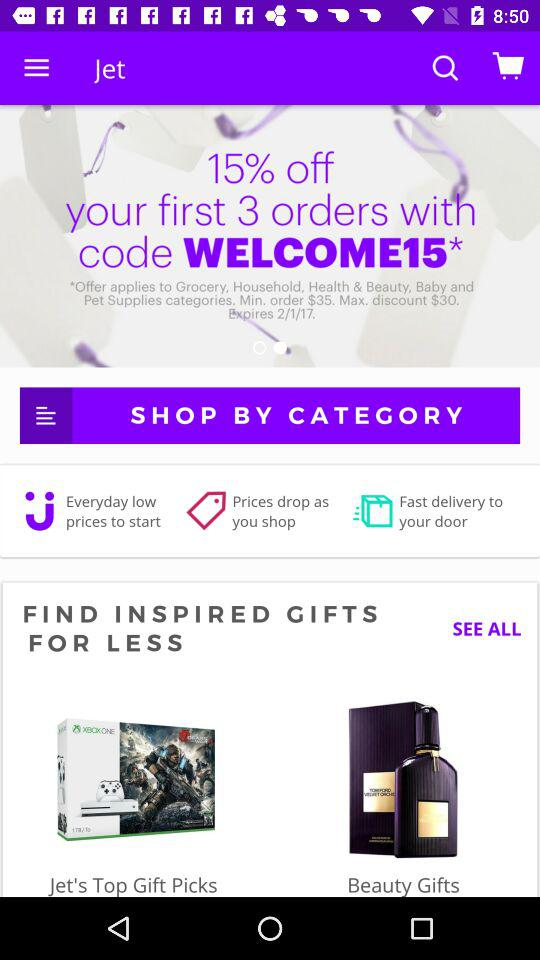What is the discount code? The discount code is WELCOME*. 